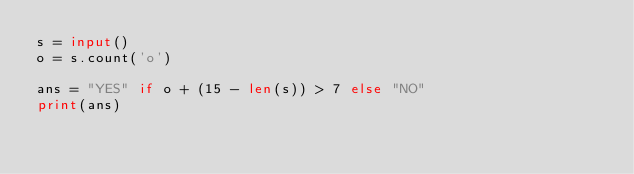Convert code to text. <code><loc_0><loc_0><loc_500><loc_500><_Python_>s = input()
o = s.count('o')

ans = "YES" if o + (15 - len(s)) > 7 else "NO"
print(ans)</code> 